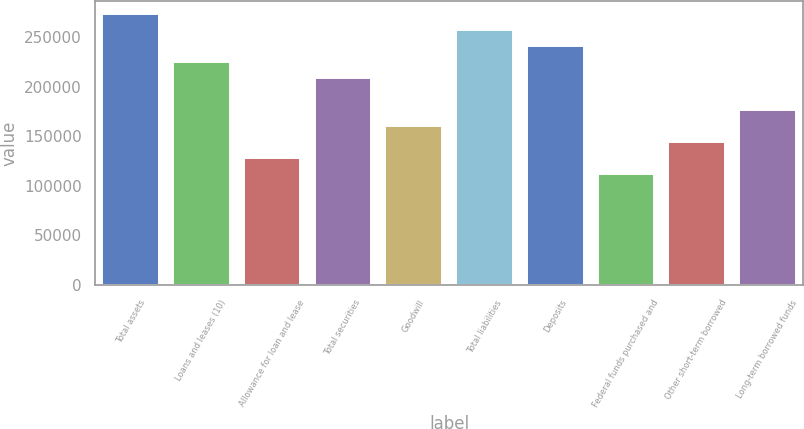<chart> <loc_0><loc_0><loc_500><loc_500><bar_chart><fcel>Total assets<fcel>Loans and leases (10)<fcel>Allowance for loan and lease<fcel>Total securities<fcel>Goodwill<fcel>Total liabilities<fcel>Deposits<fcel>Federal funds purchased and<fcel>Other short-term borrowed<fcel>Long-term borrowed funds<nl><fcel>272880<fcel>224725<fcel>128415<fcel>208673<fcel>160518<fcel>256828<fcel>240777<fcel>112363<fcel>144466<fcel>176570<nl></chart> 